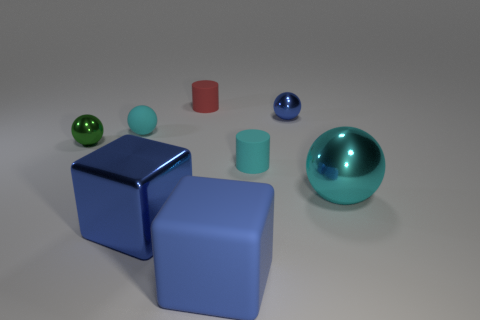Add 1 big balls. How many objects exist? 9 Subtract all cubes. How many objects are left? 6 Add 4 green spheres. How many green spheres exist? 5 Subtract 0 purple balls. How many objects are left? 8 Subtract all blue metallic things. Subtract all blue rubber cubes. How many objects are left? 5 Add 8 small cylinders. How many small cylinders are left? 10 